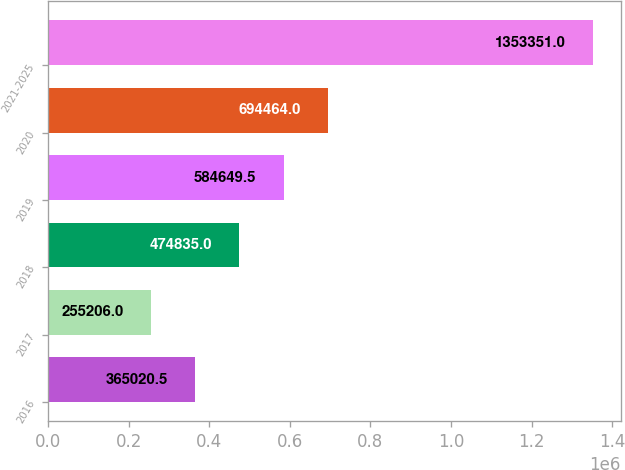Convert chart. <chart><loc_0><loc_0><loc_500><loc_500><bar_chart><fcel>2016<fcel>2017<fcel>2018<fcel>2019<fcel>2020<fcel>2021-2025<nl><fcel>365020<fcel>255206<fcel>474835<fcel>584650<fcel>694464<fcel>1.35335e+06<nl></chart> 